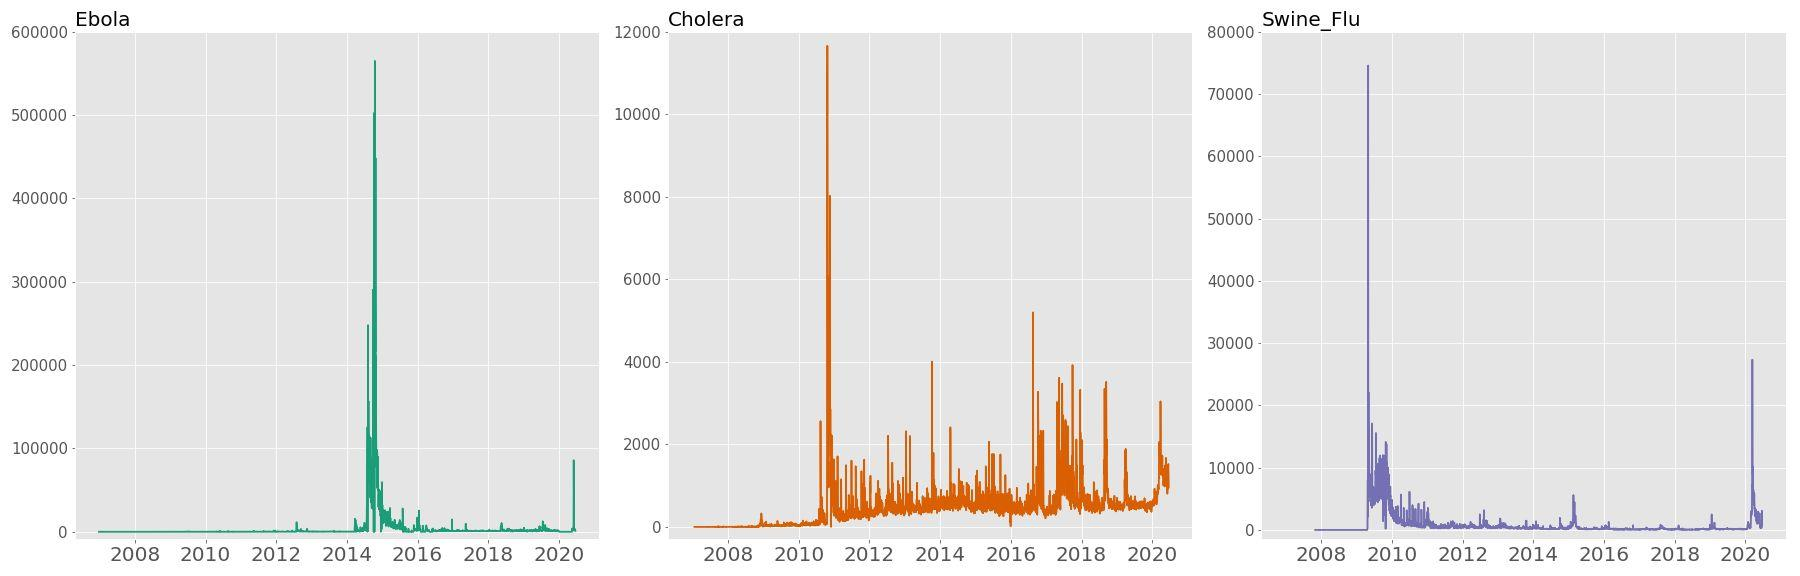Comparing the three diseases, which seems to have the most enduring impact on search trends? Upon comparing the search frequency graphs of Ebola, Cholera, and Swine Flu, we can deduce that Swine Flu has had the most enduring impact on search trends. This is indicated by both the significant initial spike, aligned with the 2009 pandemic, and the sustained baseline searches that continue beyond the initial event. While Ebola had a dramatic peak in 2014, and Cholera has seen several spikes, the Swine Flu graph suggests long-term public engagement with the topic. 